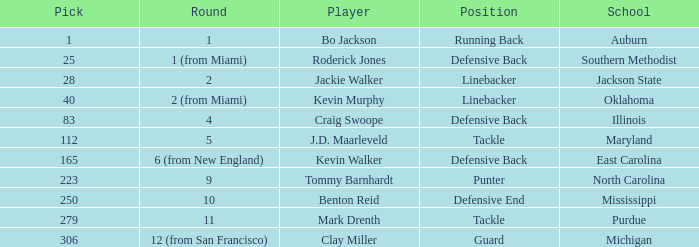What is the highest pick for a player from auburn? 1.0. 